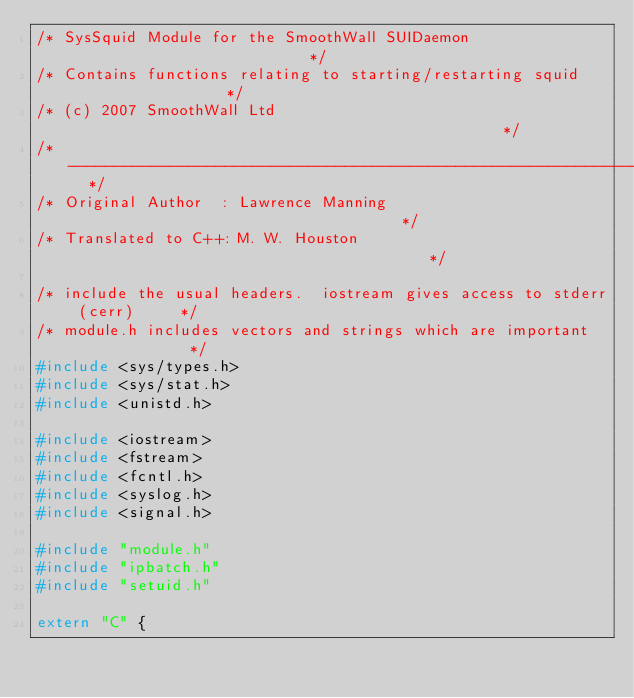<code> <loc_0><loc_0><loc_500><loc_500><_C++_>/* SysSquid Module for the SmoothWall SUIDaemon                           */
/* Contains functions relating to starting/restarting squid                  */
/* (c) 2007 SmoothWall Ltd                                                */
/* ----------------------------------------------------------------------  */
/* Original Author  : Lawrence Manning                                     */
/* Translated to C++: M. W. Houston                                        */

/* include the usual headers.  iostream gives access to stderr (cerr)     */
/* module.h includes vectors and strings which are important              */
#include <sys/types.h>
#include <sys/stat.h>
#include <unistd.h>

#include <iostream>
#include <fstream>
#include <fcntl.h>
#include <syslog.h>
#include <signal.h>

#include "module.h"
#include "ipbatch.h"
#include "setuid.h"

extern "C" {</code> 